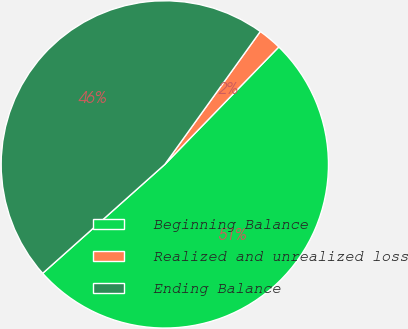Convert chart to OTSL. <chart><loc_0><loc_0><loc_500><loc_500><pie_chart><fcel>Beginning Balance<fcel>Realized and unrealized loss<fcel>Ending Balance<nl><fcel>51.15%<fcel>2.35%<fcel>46.5%<nl></chart> 